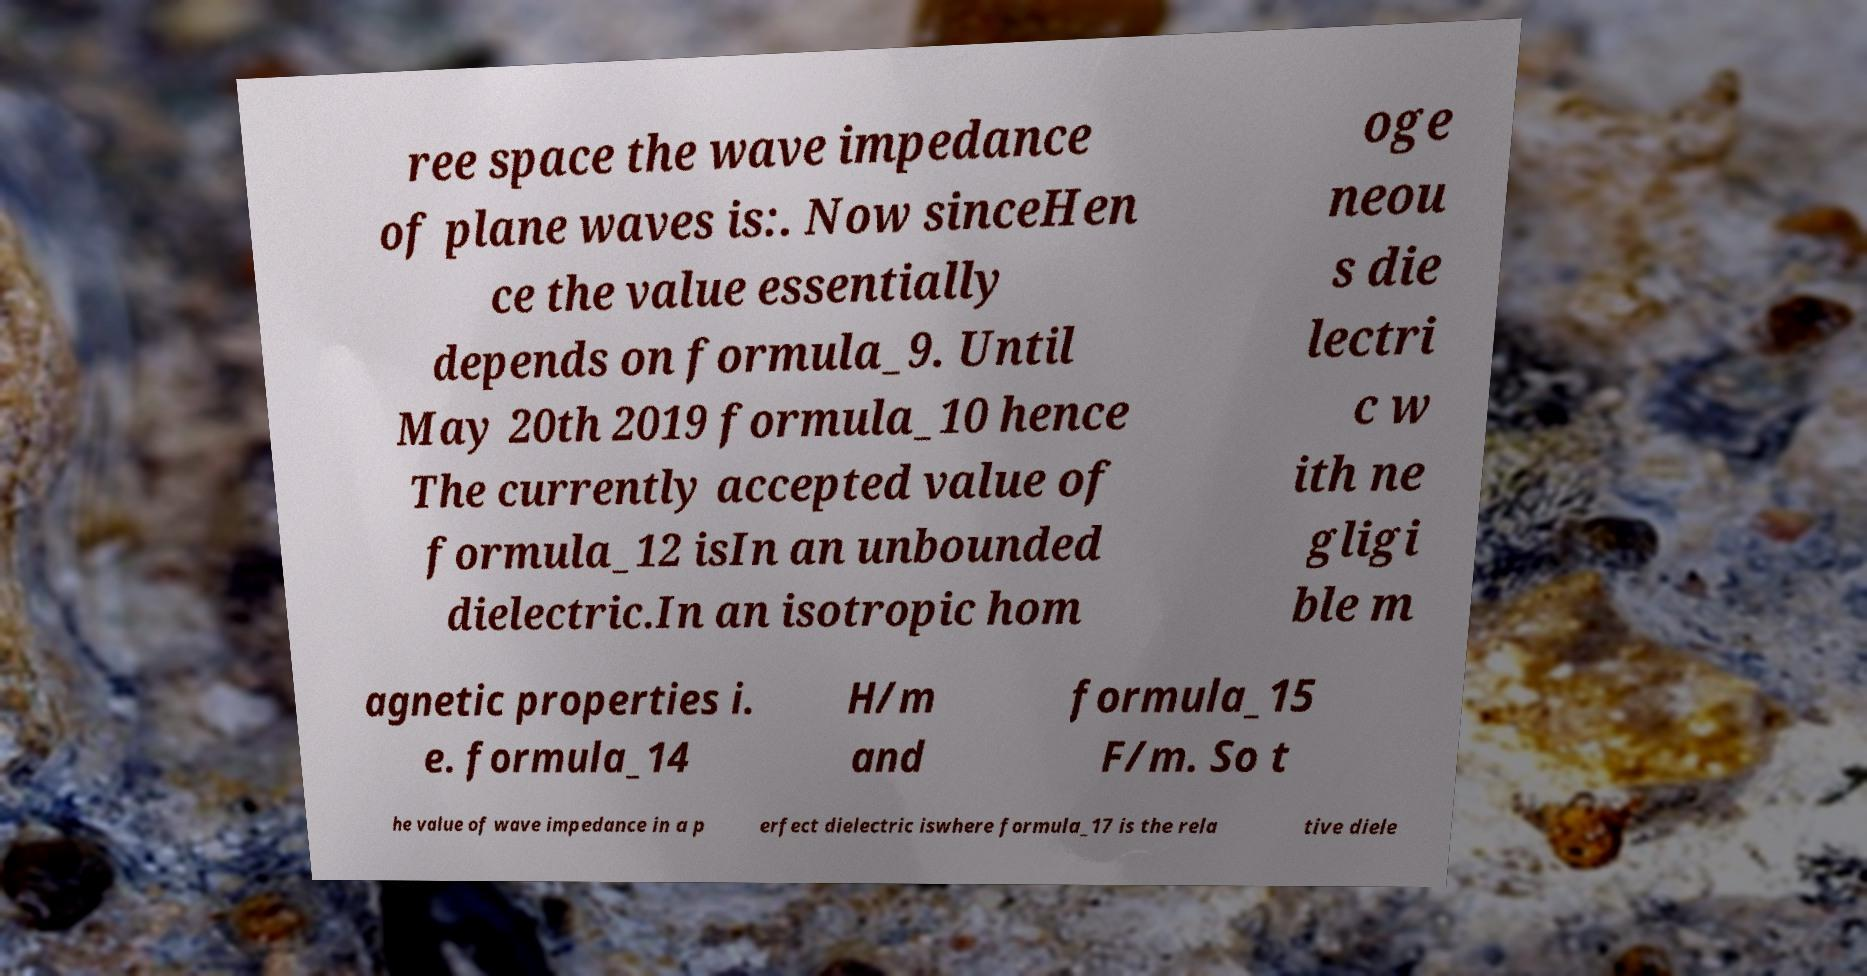Please read and relay the text visible in this image. What does it say? ree space the wave impedance of plane waves is:. Now sinceHen ce the value essentially depends on formula_9. Until May 20th 2019 formula_10 hence The currently accepted value of formula_12 isIn an unbounded dielectric.In an isotropic hom oge neou s die lectri c w ith ne gligi ble m agnetic properties i. e. formula_14 H/m and formula_15 F/m. So t he value of wave impedance in a p erfect dielectric iswhere formula_17 is the rela tive diele 